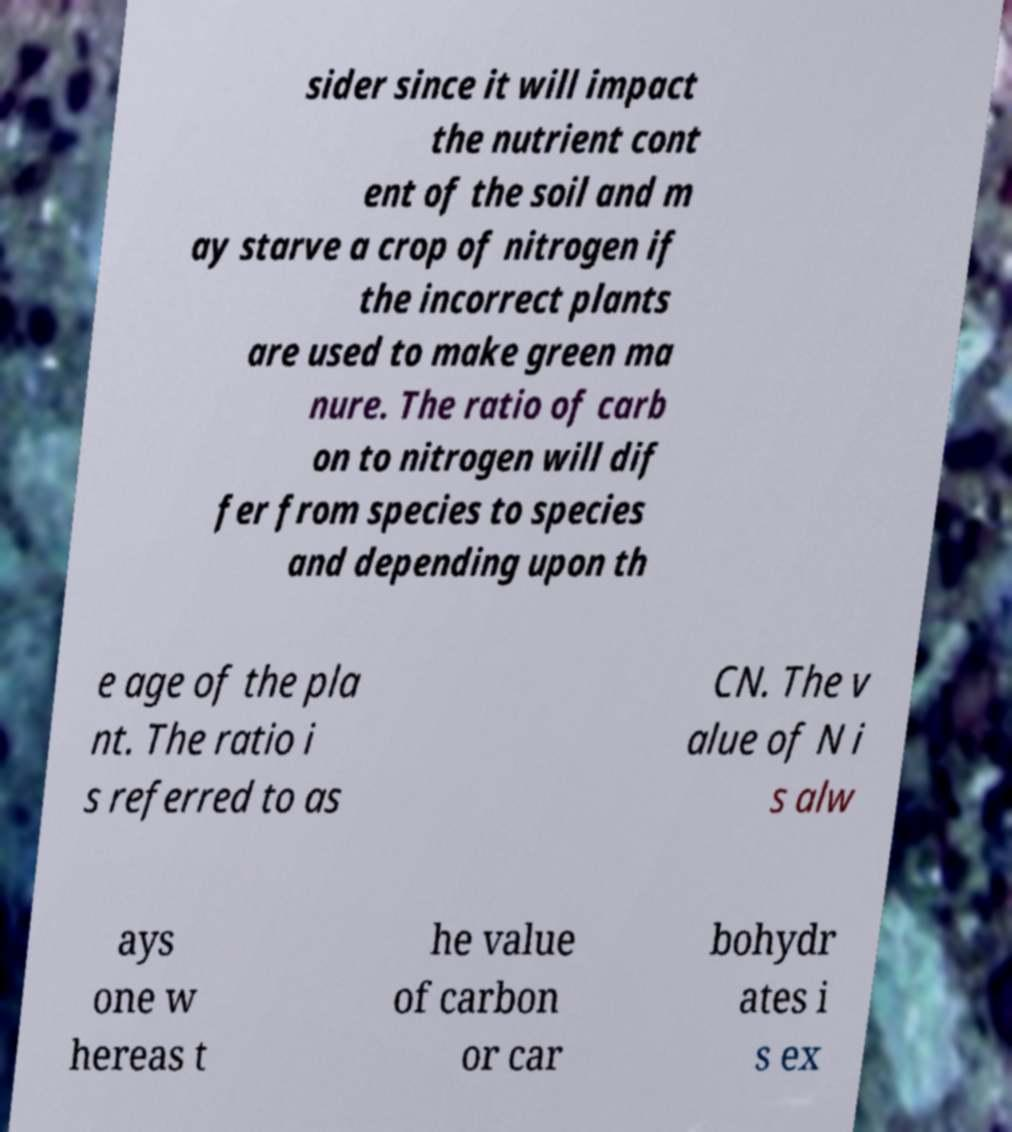Please identify and transcribe the text found in this image. sider since it will impact the nutrient cont ent of the soil and m ay starve a crop of nitrogen if the incorrect plants are used to make green ma nure. The ratio of carb on to nitrogen will dif fer from species to species and depending upon th e age of the pla nt. The ratio i s referred to as CN. The v alue of N i s alw ays one w hereas t he value of carbon or car bohydr ates i s ex 